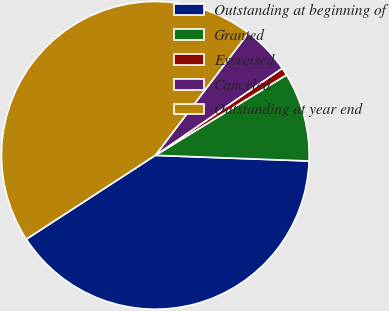<chart> <loc_0><loc_0><loc_500><loc_500><pie_chart><fcel>Outstanding at beginning of<fcel>Granted<fcel>Exercised<fcel>Canceled<fcel>Outstanding at year end<nl><fcel>40.24%<fcel>9.34%<fcel>0.82%<fcel>5.08%<fcel>44.51%<nl></chart> 